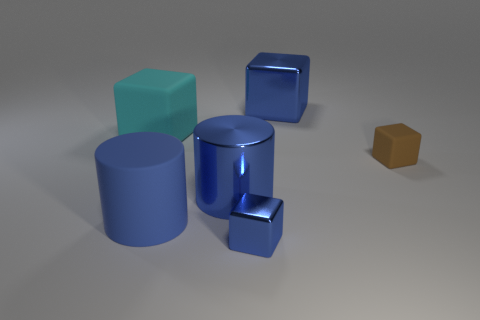How many small shiny objects are there?
Give a very brief answer. 1. Are there any red matte cylinders of the same size as the cyan thing?
Keep it short and to the point. No. Is the number of big blue blocks that are in front of the big blue matte thing less than the number of brown blocks?
Give a very brief answer. Yes. Do the blue matte thing and the brown thing have the same size?
Keep it short and to the point. No. There is a blue cylinder that is the same material as the small brown block; what is its size?
Make the answer very short. Large. How many big shiny cylinders have the same color as the small metal cube?
Your response must be concise. 1. Is the number of blue metallic cubes behind the brown object less than the number of blue shiny cylinders that are to the left of the big blue cube?
Your response must be concise. No. Do the tiny object behind the big blue metal cylinder and the blue matte object have the same shape?
Provide a short and direct response. No. Is there anything else that is made of the same material as the small brown block?
Your answer should be very brief. Yes. Are the blue block that is in front of the small brown rubber thing and the large cyan block made of the same material?
Your answer should be very brief. No. 